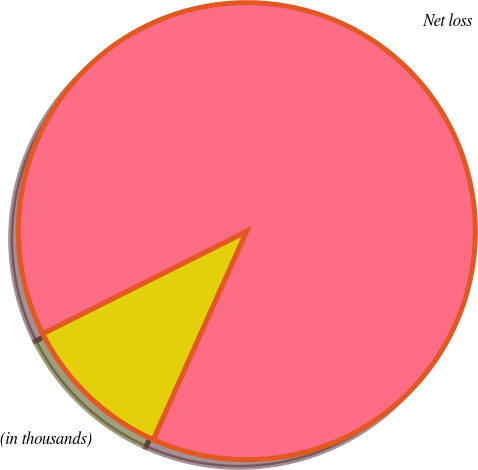<chart> <loc_0><loc_0><loc_500><loc_500><pie_chart><fcel>(in thousands)<fcel>Net loss<nl><fcel>10.89%<fcel>89.11%<nl></chart> 